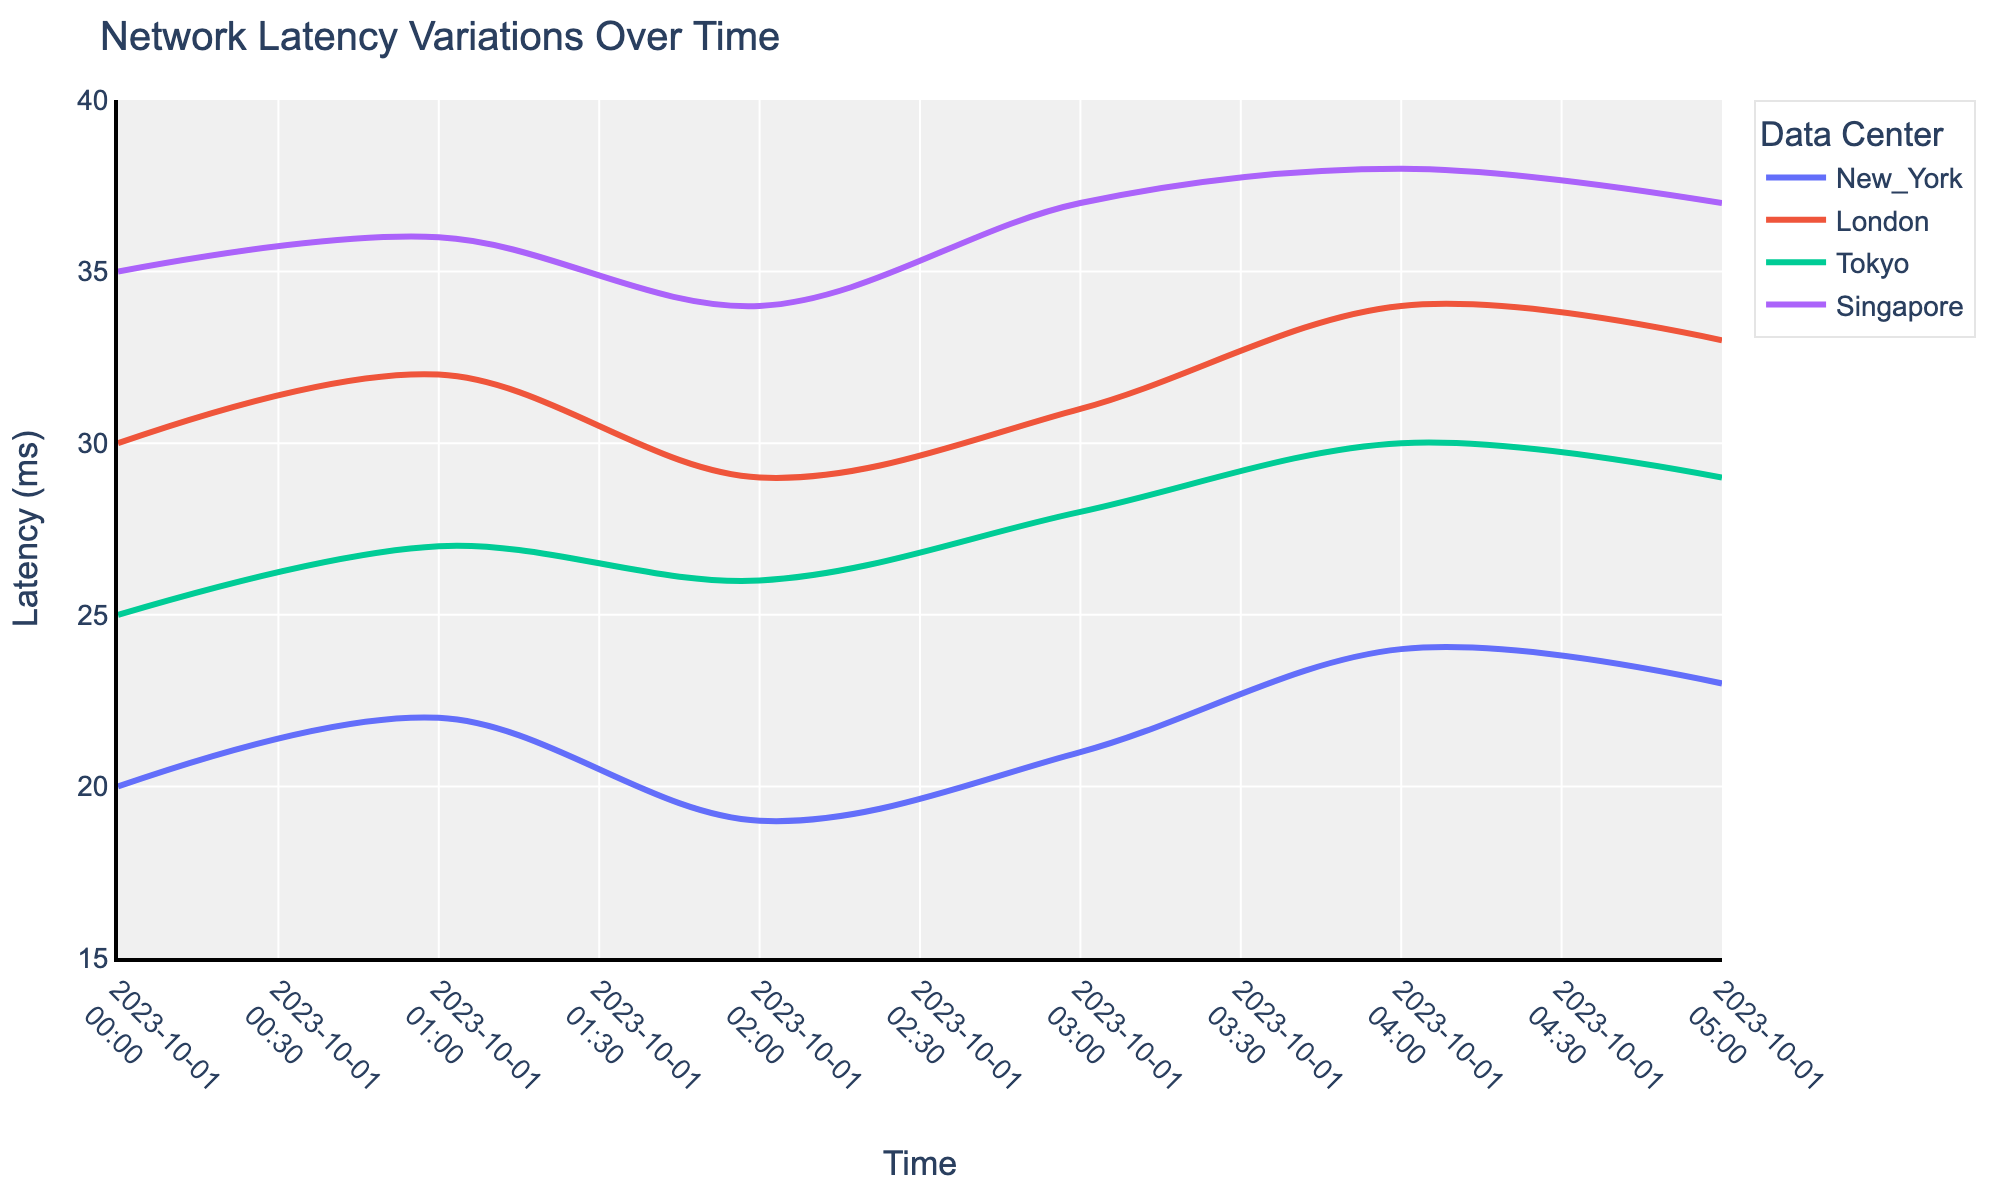What's the title of the plot? The title is displayed at the top of the figure. It indicates the main topic of the plot.
Answer: Network Latency Variations Over Time What is the range of the y-axis? The y-axis is labeled as Latency (ms). The range is determined by the highest and lowest latency values on the plot.
Answer: 15 to 40 Which data center has the highest latency at 01:00? At the timestamp 01:00, look for the highest point among all lines representing different data centers.
Answer: Singapore What is the average latency for New York between 00:00 and 05:00? Calculate the average by summing the latency values for New York (20 + 22 + 19 + 21 + 24 + 23) and dividing by the number of data points (6).
Answer: 21.5 Are there any data centers with a decreasing trend in latency over time? Observe the lines representing each data center. If a line generally slopes downwards from left to right, it indicates a decreasing trend.
Answer: No How does the latency of the London data center at 03:00 compare to its latency at 04:00? Check the latency values for London at these two timestamps. Compare them directly.
Answer: 31 at 03:00 and 34 at 04:00, so it's higher at 04:00 What is the overall trend in latency for the Tokyo data center? Look at the general direction of the line for the Tokyo data center over all timestamps.
Answer: Increasing Which two data centers have the most similar latency trends over time? Compare the shapes and directions of the lines for different data centers to find the ones that look the most similar.
Answer: Tokyo and London At what timestamp does Singapore have its maximum latency? Look for the highest point on the line representing Singapore and note the corresponding timestamp.
Answer: 04:00 Which data center has the most stable latency over time? Identify the line with the least variation (flattest line) by observing the ups and downs of each line.
Answer: New York 